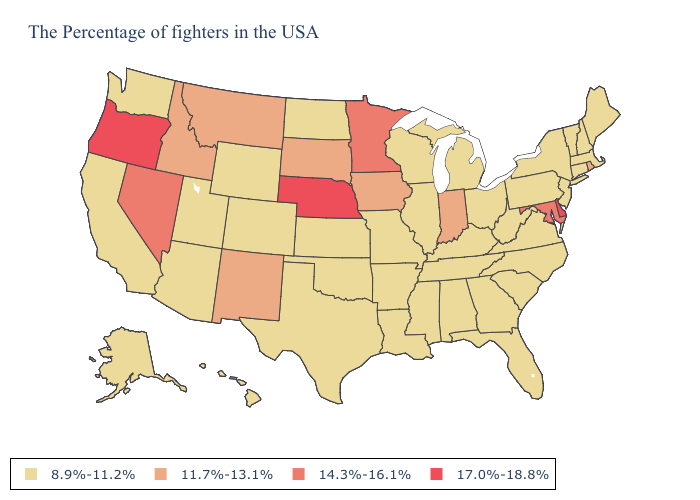What is the highest value in states that border Montana?
Quick response, please. 11.7%-13.1%. What is the highest value in the Northeast ?
Quick response, please. 11.7%-13.1%. Name the states that have a value in the range 17.0%-18.8%?
Write a very short answer. Delaware, Nebraska, Oregon. Name the states that have a value in the range 11.7%-13.1%?
Concise answer only. Rhode Island, Indiana, Iowa, South Dakota, New Mexico, Montana, Idaho. Name the states that have a value in the range 17.0%-18.8%?
Write a very short answer. Delaware, Nebraska, Oregon. Name the states that have a value in the range 17.0%-18.8%?
Short answer required. Delaware, Nebraska, Oregon. What is the lowest value in the MidWest?
Quick response, please. 8.9%-11.2%. Name the states that have a value in the range 14.3%-16.1%?
Be succinct. Maryland, Minnesota, Nevada. What is the value of North Dakota?
Give a very brief answer. 8.9%-11.2%. Which states have the lowest value in the West?
Short answer required. Wyoming, Colorado, Utah, Arizona, California, Washington, Alaska, Hawaii. What is the highest value in states that border North Dakota?
Short answer required. 14.3%-16.1%. What is the highest value in the South ?
Write a very short answer. 17.0%-18.8%. Among the states that border New Jersey , which have the highest value?
Be succinct. Delaware. Name the states that have a value in the range 14.3%-16.1%?
Be succinct. Maryland, Minnesota, Nevada. Name the states that have a value in the range 14.3%-16.1%?
Short answer required. Maryland, Minnesota, Nevada. 